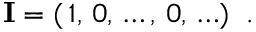Convert formula to latex. <formula><loc_0><loc_0><loc_500><loc_500>{ I } = ( \, 1 , \, 0 , \, \dots , \, 0 , \, \dots ) \, .</formula> 